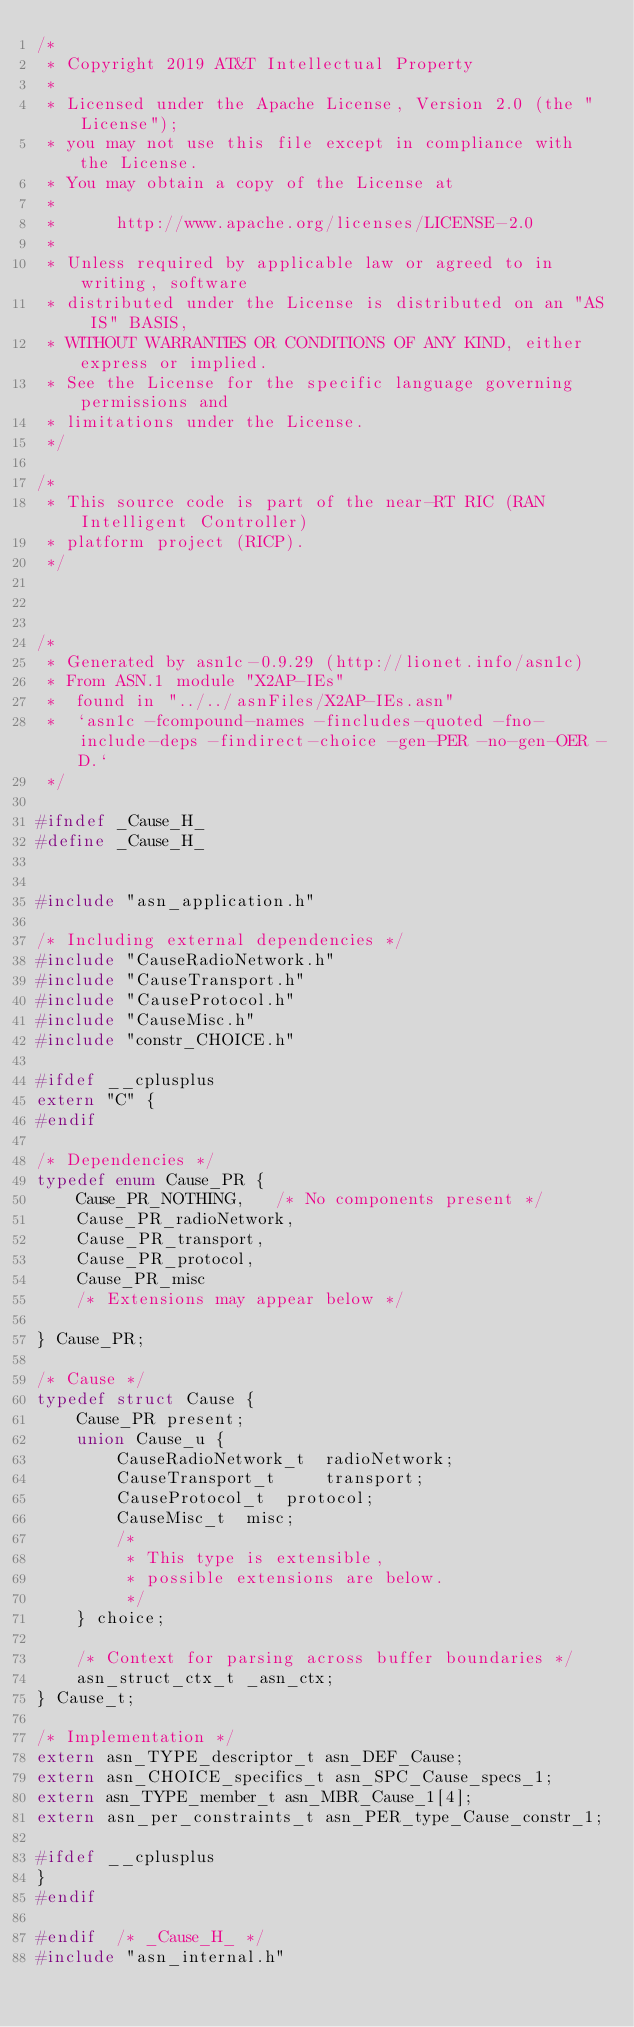<code> <loc_0><loc_0><loc_500><loc_500><_C_>/*
 * Copyright 2019 AT&T Intellectual Property
 *
 * Licensed under the Apache License, Version 2.0 (the "License");
 * you may not use this file except in compliance with the License.
 * You may obtain a copy of the License at
 *
 *      http://www.apache.org/licenses/LICENSE-2.0
 *
 * Unless required by applicable law or agreed to in writing, software
 * distributed under the License is distributed on an "AS IS" BASIS,
 * WITHOUT WARRANTIES OR CONDITIONS OF ANY KIND, either express or implied.
 * See the License for the specific language governing permissions and
 * limitations under the License.
 */

/*
 * This source code is part of the near-RT RIC (RAN Intelligent Controller)
 * platform project (RICP).
 */



/*
 * Generated by asn1c-0.9.29 (http://lionet.info/asn1c)
 * From ASN.1 module "X2AP-IEs"
 * 	found in "../../asnFiles/X2AP-IEs.asn"
 * 	`asn1c -fcompound-names -fincludes-quoted -fno-include-deps -findirect-choice -gen-PER -no-gen-OER -D.`
 */

#ifndef	_Cause_H_
#define	_Cause_H_


#include "asn_application.h"

/* Including external dependencies */
#include "CauseRadioNetwork.h"
#include "CauseTransport.h"
#include "CauseProtocol.h"
#include "CauseMisc.h"
#include "constr_CHOICE.h"

#ifdef __cplusplus
extern "C" {
#endif

/* Dependencies */
typedef enum Cause_PR {
	Cause_PR_NOTHING,	/* No components present */
	Cause_PR_radioNetwork,
	Cause_PR_transport,
	Cause_PR_protocol,
	Cause_PR_misc
	/* Extensions may appear below */
	
} Cause_PR;

/* Cause */
typedef struct Cause {
	Cause_PR present;
	union Cause_u {
		CauseRadioNetwork_t	 radioNetwork;
		CauseTransport_t	 transport;
		CauseProtocol_t	 protocol;
		CauseMisc_t	 misc;
		/*
		 * This type is extensible,
		 * possible extensions are below.
		 */
	} choice;
	
	/* Context for parsing across buffer boundaries */
	asn_struct_ctx_t _asn_ctx;
} Cause_t;

/* Implementation */
extern asn_TYPE_descriptor_t asn_DEF_Cause;
extern asn_CHOICE_specifics_t asn_SPC_Cause_specs_1;
extern asn_TYPE_member_t asn_MBR_Cause_1[4];
extern asn_per_constraints_t asn_PER_type_Cause_constr_1;

#ifdef __cplusplus
}
#endif

#endif	/* _Cause_H_ */
#include "asn_internal.h"
</code> 